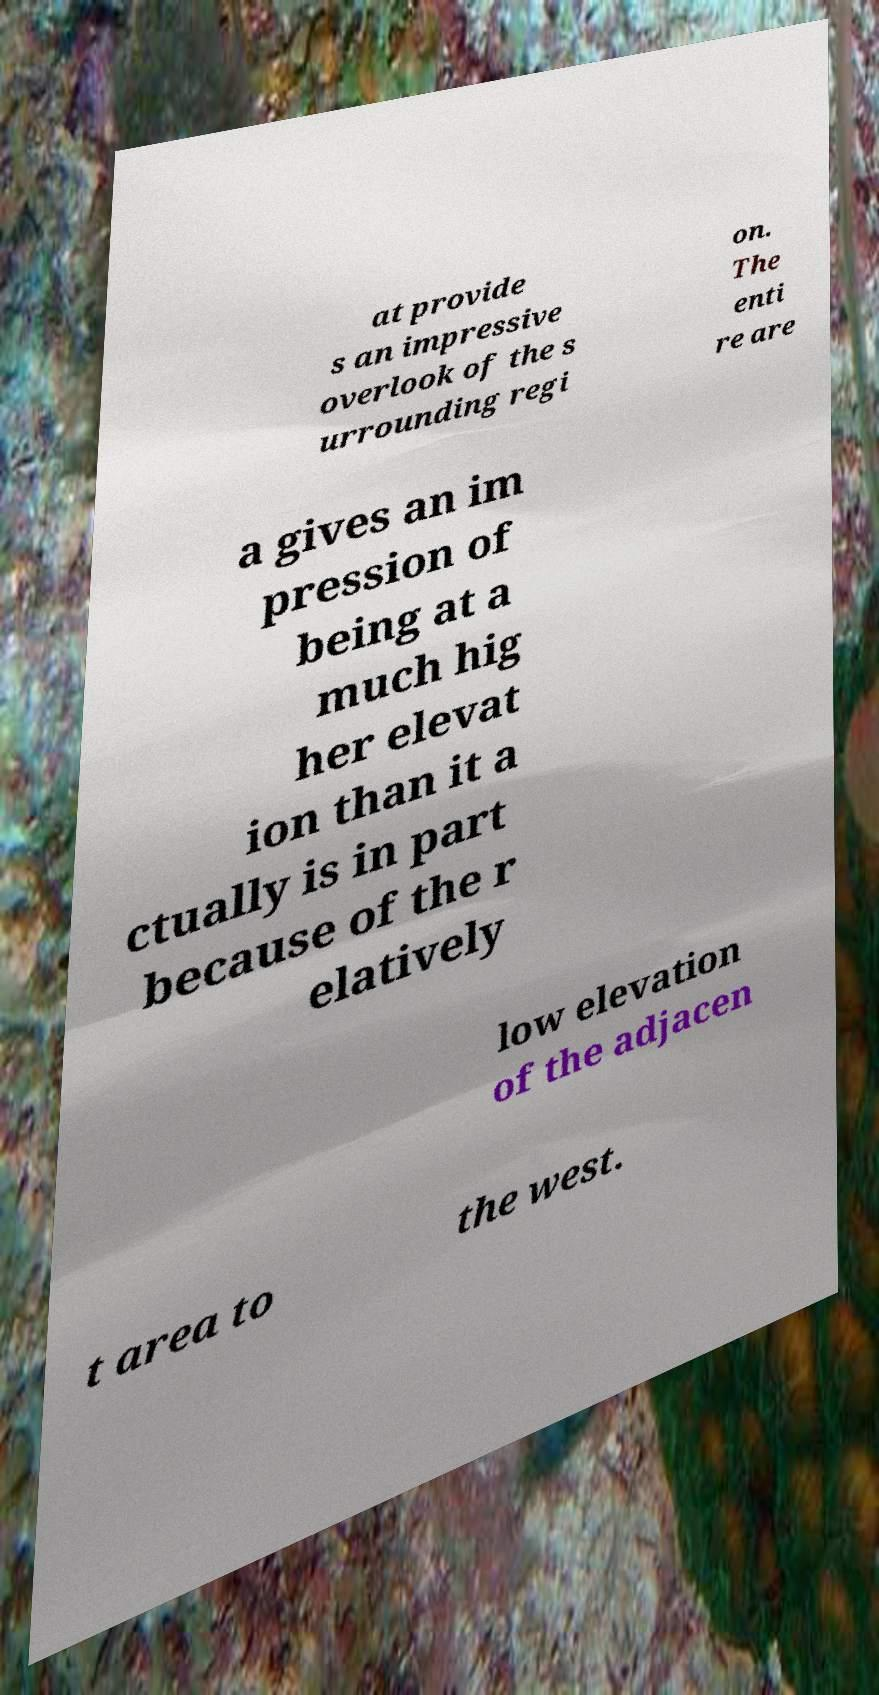For documentation purposes, I need the text within this image transcribed. Could you provide that? at provide s an impressive overlook of the s urrounding regi on. The enti re are a gives an im pression of being at a much hig her elevat ion than it a ctually is in part because of the r elatively low elevation of the adjacen t area to the west. 